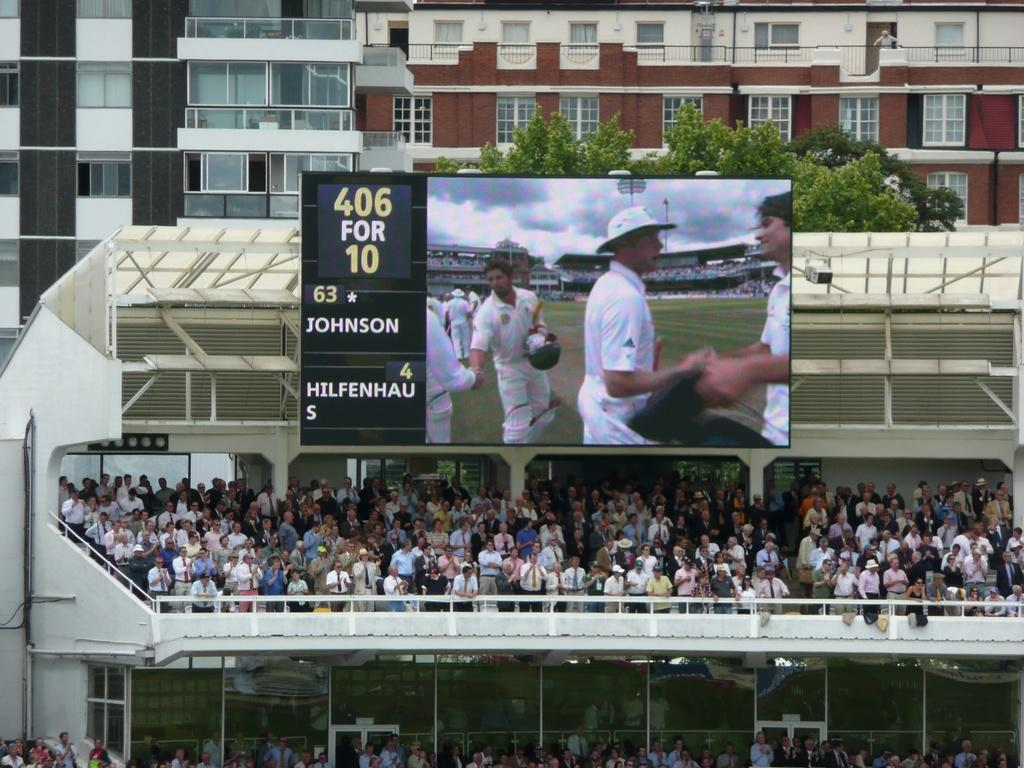<image>
Describe the image concisely. A sign at a stadium reads "406 FOR 10 63 JOHNSON 4 HILFENHAUS." 